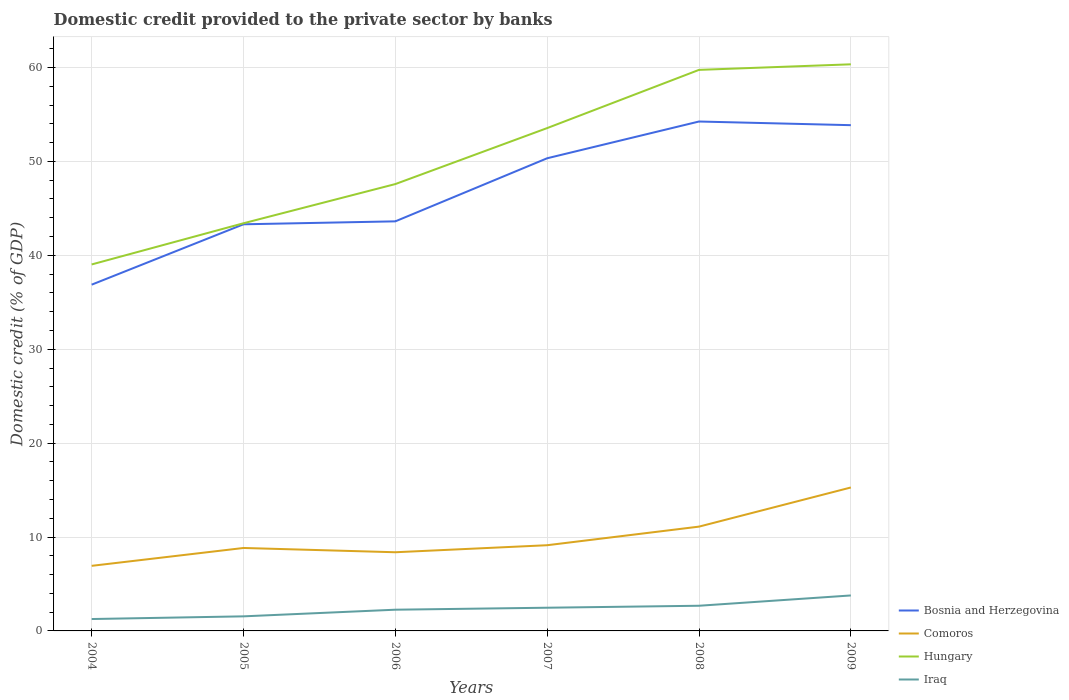Does the line corresponding to Bosnia and Herzegovina intersect with the line corresponding to Hungary?
Offer a very short reply. No. Is the number of lines equal to the number of legend labels?
Your answer should be very brief. Yes. Across all years, what is the maximum domestic credit provided to the private sector by banks in Comoros?
Your response must be concise. 6.93. In which year was the domestic credit provided to the private sector by banks in Iraq maximum?
Your answer should be compact. 2004. What is the total domestic credit provided to the private sector by banks in Hungary in the graph?
Provide a succinct answer. -6.79. What is the difference between the highest and the second highest domestic credit provided to the private sector by banks in Hungary?
Give a very brief answer. 21.31. What is the difference between the highest and the lowest domestic credit provided to the private sector by banks in Hungary?
Your answer should be compact. 3. Is the domestic credit provided to the private sector by banks in Hungary strictly greater than the domestic credit provided to the private sector by banks in Iraq over the years?
Give a very brief answer. No. What is the difference between two consecutive major ticks on the Y-axis?
Your answer should be very brief. 10. Are the values on the major ticks of Y-axis written in scientific E-notation?
Keep it short and to the point. No. Does the graph contain any zero values?
Keep it short and to the point. No. What is the title of the graph?
Your answer should be compact. Domestic credit provided to the private sector by banks. Does "North America" appear as one of the legend labels in the graph?
Make the answer very short. No. What is the label or title of the Y-axis?
Your response must be concise. Domestic credit (% of GDP). What is the Domestic credit (% of GDP) of Bosnia and Herzegovina in 2004?
Your response must be concise. 36.88. What is the Domestic credit (% of GDP) in Comoros in 2004?
Provide a succinct answer. 6.93. What is the Domestic credit (% of GDP) of Hungary in 2004?
Offer a terse response. 39.03. What is the Domestic credit (% of GDP) of Iraq in 2004?
Provide a succinct answer. 1.27. What is the Domestic credit (% of GDP) of Bosnia and Herzegovina in 2005?
Give a very brief answer. 43.31. What is the Domestic credit (% of GDP) of Comoros in 2005?
Give a very brief answer. 8.83. What is the Domestic credit (% of GDP) in Hungary in 2005?
Your response must be concise. 43.42. What is the Domestic credit (% of GDP) of Iraq in 2005?
Provide a succinct answer. 1.55. What is the Domestic credit (% of GDP) of Bosnia and Herzegovina in 2006?
Make the answer very short. 43.62. What is the Domestic credit (% of GDP) in Comoros in 2006?
Keep it short and to the point. 8.38. What is the Domestic credit (% of GDP) in Hungary in 2006?
Keep it short and to the point. 47.59. What is the Domestic credit (% of GDP) of Iraq in 2006?
Keep it short and to the point. 2.26. What is the Domestic credit (% of GDP) in Bosnia and Herzegovina in 2007?
Make the answer very short. 50.34. What is the Domestic credit (% of GDP) of Comoros in 2007?
Your answer should be very brief. 9.13. What is the Domestic credit (% of GDP) in Hungary in 2007?
Your answer should be very brief. 53.55. What is the Domestic credit (% of GDP) in Iraq in 2007?
Your response must be concise. 2.47. What is the Domestic credit (% of GDP) in Bosnia and Herzegovina in 2008?
Make the answer very short. 54.25. What is the Domestic credit (% of GDP) of Comoros in 2008?
Ensure brevity in your answer.  11.11. What is the Domestic credit (% of GDP) in Hungary in 2008?
Keep it short and to the point. 59.75. What is the Domestic credit (% of GDP) in Iraq in 2008?
Provide a short and direct response. 2.68. What is the Domestic credit (% of GDP) in Bosnia and Herzegovina in 2009?
Offer a very short reply. 53.86. What is the Domestic credit (% of GDP) in Comoros in 2009?
Provide a succinct answer. 15.28. What is the Domestic credit (% of GDP) of Hungary in 2009?
Your answer should be compact. 60.34. What is the Domestic credit (% of GDP) in Iraq in 2009?
Provide a short and direct response. 3.78. Across all years, what is the maximum Domestic credit (% of GDP) of Bosnia and Herzegovina?
Provide a succinct answer. 54.25. Across all years, what is the maximum Domestic credit (% of GDP) of Comoros?
Your answer should be compact. 15.28. Across all years, what is the maximum Domestic credit (% of GDP) in Hungary?
Your response must be concise. 60.34. Across all years, what is the maximum Domestic credit (% of GDP) in Iraq?
Give a very brief answer. 3.78. Across all years, what is the minimum Domestic credit (% of GDP) of Bosnia and Herzegovina?
Keep it short and to the point. 36.88. Across all years, what is the minimum Domestic credit (% of GDP) in Comoros?
Make the answer very short. 6.93. Across all years, what is the minimum Domestic credit (% of GDP) in Hungary?
Offer a terse response. 39.03. Across all years, what is the minimum Domestic credit (% of GDP) of Iraq?
Ensure brevity in your answer.  1.27. What is the total Domestic credit (% of GDP) in Bosnia and Herzegovina in the graph?
Keep it short and to the point. 282.25. What is the total Domestic credit (% of GDP) of Comoros in the graph?
Provide a short and direct response. 59.66. What is the total Domestic credit (% of GDP) of Hungary in the graph?
Keep it short and to the point. 303.68. What is the total Domestic credit (% of GDP) of Iraq in the graph?
Keep it short and to the point. 14.01. What is the difference between the Domestic credit (% of GDP) of Bosnia and Herzegovina in 2004 and that in 2005?
Your response must be concise. -6.43. What is the difference between the Domestic credit (% of GDP) in Comoros in 2004 and that in 2005?
Ensure brevity in your answer.  -1.9. What is the difference between the Domestic credit (% of GDP) in Hungary in 2004 and that in 2005?
Make the answer very short. -4.39. What is the difference between the Domestic credit (% of GDP) in Iraq in 2004 and that in 2005?
Keep it short and to the point. -0.29. What is the difference between the Domestic credit (% of GDP) in Bosnia and Herzegovina in 2004 and that in 2006?
Keep it short and to the point. -6.74. What is the difference between the Domestic credit (% of GDP) in Comoros in 2004 and that in 2006?
Your response must be concise. -1.45. What is the difference between the Domestic credit (% of GDP) of Hungary in 2004 and that in 2006?
Make the answer very short. -8.56. What is the difference between the Domestic credit (% of GDP) of Iraq in 2004 and that in 2006?
Ensure brevity in your answer.  -0.99. What is the difference between the Domestic credit (% of GDP) in Bosnia and Herzegovina in 2004 and that in 2007?
Offer a terse response. -13.46. What is the difference between the Domestic credit (% of GDP) of Comoros in 2004 and that in 2007?
Make the answer very short. -2.2. What is the difference between the Domestic credit (% of GDP) in Hungary in 2004 and that in 2007?
Offer a terse response. -14.52. What is the difference between the Domestic credit (% of GDP) of Iraq in 2004 and that in 2007?
Provide a short and direct response. -1.21. What is the difference between the Domestic credit (% of GDP) in Bosnia and Herzegovina in 2004 and that in 2008?
Ensure brevity in your answer.  -17.38. What is the difference between the Domestic credit (% of GDP) of Comoros in 2004 and that in 2008?
Offer a terse response. -4.18. What is the difference between the Domestic credit (% of GDP) in Hungary in 2004 and that in 2008?
Your answer should be very brief. -20.72. What is the difference between the Domestic credit (% of GDP) in Iraq in 2004 and that in 2008?
Keep it short and to the point. -1.41. What is the difference between the Domestic credit (% of GDP) of Bosnia and Herzegovina in 2004 and that in 2009?
Give a very brief answer. -16.98. What is the difference between the Domestic credit (% of GDP) in Comoros in 2004 and that in 2009?
Ensure brevity in your answer.  -8.34. What is the difference between the Domestic credit (% of GDP) in Hungary in 2004 and that in 2009?
Your answer should be very brief. -21.31. What is the difference between the Domestic credit (% of GDP) in Iraq in 2004 and that in 2009?
Your answer should be very brief. -2.51. What is the difference between the Domestic credit (% of GDP) of Bosnia and Herzegovina in 2005 and that in 2006?
Ensure brevity in your answer.  -0.31. What is the difference between the Domestic credit (% of GDP) in Comoros in 2005 and that in 2006?
Offer a very short reply. 0.45. What is the difference between the Domestic credit (% of GDP) of Hungary in 2005 and that in 2006?
Give a very brief answer. -4.17. What is the difference between the Domestic credit (% of GDP) of Iraq in 2005 and that in 2006?
Ensure brevity in your answer.  -0.71. What is the difference between the Domestic credit (% of GDP) of Bosnia and Herzegovina in 2005 and that in 2007?
Your answer should be very brief. -7.03. What is the difference between the Domestic credit (% of GDP) of Comoros in 2005 and that in 2007?
Offer a very short reply. -0.29. What is the difference between the Domestic credit (% of GDP) of Hungary in 2005 and that in 2007?
Keep it short and to the point. -10.14. What is the difference between the Domestic credit (% of GDP) of Iraq in 2005 and that in 2007?
Keep it short and to the point. -0.92. What is the difference between the Domestic credit (% of GDP) of Bosnia and Herzegovina in 2005 and that in 2008?
Offer a very short reply. -10.95. What is the difference between the Domestic credit (% of GDP) in Comoros in 2005 and that in 2008?
Your response must be concise. -2.27. What is the difference between the Domestic credit (% of GDP) of Hungary in 2005 and that in 2008?
Provide a succinct answer. -16.33. What is the difference between the Domestic credit (% of GDP) of Iraq in 2005 and that in 2008?
Your response must be concise. -1.13. What is the difference between the Domestic credit (% of GDP) in Bosnia and Herzegovina in 2005 and that in 2009?
Your answer should be very brief. -10.56. What is the difference between the Domestic credit (% of GDP) in Comoros in 2005 and that in 2009?
Give a very brief answer. -6.44. What is the difference between the Domestic credit (% of GDP) in Hungary in 2005 and that in 2009?
Offer a terse response. -16.93. What is the difference between the Domestic credit (% of GDP) in Iraq in 2005 and that in 2009?
Give a very brief answer. -2.23. What is the difference between the Domestic credit (% of GDP) of Bosnia and Herzegovina in 2006 and that in 2007?
Your answer should be compact. -6.72. What is the difference between the Domestic credit (% of GDP) of Comoros in 2006 and that in 2007?
Give a very brief answer. -0.75. What is the difference between the Domestic credit (% of GDP) of Hungary in 2006 and that in 2007?
Give a very brief answer. -5.96. What is the difference between the Domestic credit (% of GDP) in Iraq in 2006 and that in 2007?
Your answer should be compact. -0.21. What is the difference between the Domestic credit (% of GDP) in Bosnia and Herzegovina in 2006 and that in 2008?
Your answer should be compact. -10.63. What is the difference between the Domestic credit (% of GDP) in Comoros in 2006 and that in 2008?
Your answer should be very brief. -2.73. What is the difference between the Domestic credit (% of GDP) of Hungary in 2006 and that in 2008?
Keep it short and to the point. -12.16. What is the difference between the Domestic credit (% of GDP) of Iraq in 2006 and that in 2008?
Keep it short and to the point. -0.42. What is the difference between the Domestic credit (% of GDP) of Bosnia and Herzegovina in 2006 and that in 2009?
Your response must be concise. -10.24. What is the difference between the Domestic credit (% of GDP) of Comoros in 2006 and that in 2009?
Your answer should be very brief. -6.9. What is the difference between the Domestic credit (% of GDP) in Hungary in 2006 and that in 2009?
Ensure brevity in your answer.  -12.75. What is the difference between the Domestic credit (% of GDP) in Iraq in 2006 and that in 2009?
Offer a very short reply. -1.52. What is the difference between the Domestic credit (% of GDP) in Bosnia and Herzegovina in 2007 and that in 2008?
Make the answer very short. -3.91. What is the difference between the Domestic credit (% of GDP) of Comoros in 2007 and that in 2008?
Your response must be concise. -1.98. What is the difference between the Domestic credit (% of GDP) of Hungary in 2007 and that in 2008?
Offer a terse response. -6.2. What is the difference between the Domestic credit (% of GDP) of Iraq in 2007 and that in 2008?
Your answer should be very brief. -0.21. What is the difference between the Domestic credit (% of GDP) of Bosnia and Herzegovina in 2007 and that in 2009?
Give a very brief answer. -3.52. What is the difference between the Domestic credit (% of GDP) in Comoros in 2007 and that in 2009?
Provide a short and direct response. -6.15. What is the difference between the Domestic credit (% of GDP) of Hungary in 2007 and that in 2009?
Make the answer very short. -6.79. What is the difference between the Domestic credit (% of GDP) in Iraq in 2007 and that in 2009?
Keep it short and to the point. -1.31. What is the difference between the Domestic credit (% of GDP) in Bosnia and Herzegovina in 2008 and that in 2009?
Offer a very short reply. 0.39. What is the difference between the Domestic credit (% of GDP) in Comoros in 2008 and that in 2009?
Your response must be concise. -4.17. What is the difference between the Domestic credit (% of GDP) in Hungary in 2008 and that in 2009?
Offer a very short reply. -0.59. What is the difference between the Domestic credit (% of GDP) of Iraq in 2008 and that in 2009?
Make the answer very short. -1.1. What is the difference between the Domestic credit (% of GDP) of Bosnia and Herzegovina in 2004 and the Domestic credit (% of GDP) of Comoros in 2005?
Provide a short and direct response. 28.04. What is the difference between the Domestic credit (% of GDP) in Bosnia and Herzegovina in 2004 and the Domestic credit (% of GDP) in Hungary in 2005?
Your answer should be very brief. -6.54. What is the difference between the Domestic credit (% of GDP) of Bosnia and Herzegovina in 2004 and the Domestic credit (% of GDP) of Iraq in 2005?
Keep it short and to the point. 35.33. What is the difference between the Domestic credit (% of GDP) in Comoros in 2004 and the Domestic credit (% of GDP) in Hungary in 2005?
Your answer should be compact. -36.48. What is the difference between the Domestic credit (% of GDP) in Comoros in 2004 and the Domestic credit (% of GDP) in Iraq in 2005?
Give a very brief answer. 5.38. What is the difference between the Domestic credit (% of GDP) of Hungary in 2004 and the Domestic credit (% of GDP) of Iraq in 2005?
Offer a very short reply. 37.48. What is the difference between the Domestic credit (% of GDP) of Bosnia and Herzegovina in 2004 and the Domestic credit (% of GDP) of Comoros in 2006?
Your answer should be compact. 28.5. What is the difference between the Domestic credit (% of GDP) in Bosnia and Herzegovina in 2004 and the Domestic credit (% of GDP) in Hungary in 2006?
Your response must be concise. -10.71. What is the difference between the Domestic credit (% of GDP) in Bosnia and Herzegovina in 2004 and the Domestic credit (% of GDP) in Iraq in 2006?
Provide a succinct answer. 34.62. What is the difference between the Domestic credit (% of GDP) in Comoros in 2004 and the Domestic credit (% of GDP) in Hungary in 2006?
Give a very brief answer. -40.66. What is the difference between the Domestic credit (% of GDP) in Comoros in 2004 and the Domestic credit (% of GDP) in Iraq in 2006?
Your answer should be very brief. 4.67. What is the difference between the Domestic credit (% of GDP) of Hungary in 2004 and the Domestic credit (% of GDP) of Iraq in 2006?
Give a very brief answer. 36.77. What is the difference between the Domestic credit (% of GDP) of Bosnia and Herzegovina in 2004 and the Domestic credit (% of GDP) of Comoros in 2007?
Your answer should be very brief. 27.75. What is the difference between the Domestic credit (% of GDP) in Bosnia and Herzegovina in 2004 and the Domestic credit (% of GDP) in Hungary in 2007?
Provide a succinct answer. -16.68. What is the difference between the Domestic credit (% of GDP) of Bosnia and Herzegovina in 2004 and the Domestic credit (% of GDP) of Iraq in 2007?
Your answer should be compact. 34.41. What is the difference between the Domestic credit (% of GDP) of Comoros in 2004 and the Domestic credit (% of GDP) of Hungary in 2007?
Provide a succinct answer. -46.62. What is the difference between the Domestic credit (% of GDP) of Comoros in 2004 and the Domestic credit (% of GDP) of Iraq in 2007?
Give a very brief answer. 4.46. What is the difference between the Domestic credit (% of GDP) in Hungary in 2004 and the Domestic credit (% of GDP) in Iraq in 2007?
Your response must be concise. 36.56. What is the difference between the Domestic credit (% of GDP) in Bosnia and Herzegovina in 2004 and the Domestic credit (% of GDP) in Comoros in 2008?
Provide a succinct answer. 25.77. What is the difference between the Domestic credit (% of GDP) of Bosnia and Herzegovina in 2004 and the Domestic credit (% of GDP) of Hungary in 2008?
Your answer should be compact. -22.87. What is the difference between the Domestic credit (% of GDP) of Bosnia and Herzegovina in 2004 and the Domestic credit (% of GDP) of Iraq in 2008?
Give a very brief answer. 34.2. What is the difference between the Domestic credit (% of GDP) in Comoros in 2004 and the Domestic credit (% of GDP) in Hungary in 2008?
Provide a short and direct response. -52.82. What is the difference between the Domestic credit (% of GDP) of Comoros in 2004 and the Domestic credit (% of GDP) of Iraq in 2008?
Offer a very short reply. 4.25. What is the difference between the Domestic credit (% of GDP) in Hungary in 2004 and the Domestic credit (% of GDP) in Iraq in 2008?
Offer a very short reply. 36.35. What is the difference between the Domestic credit (% of GDP) in Bosnia and Herzegovina in 2004 and the Domestic credit (% of GDP) in Comoros in 2009?
Offer a very short reply. 21.6. What is the difference between the Domestic credit (% of GDP) in Bosnia and Herzegovina in 2004 and the Domestic credit (% of GDP) in Hungary in 2009?
Keep it short and to the point. -23.47. What is the difference between the Domestic credit (% of GDP) in Bosnia and Herzegovina in 2004 and the Domestic credit (% of GDP) in Iraq in 2009?
Your answer should be very brief. 33.1. What is the difference between the Domestic credit (% of GDP) of Comoros in 2004 and the Domestic credit (% of GDP) of Hungary in 2009?
Provide a short and direct response. -53.41. What is the difference between the Domestic credit (% of GDP) in Comoros in 2004 and the Domestic credit (% of GDP) in Iraq in 2009?
Your answer should be very brief. 3.15. What is the difference between the Domestic credit (% of GDP) of Hungary in 2004 and the Domestic credit (% of GDP) of Iraq in 2009?
Provide a short and direct response. 35.25. What is the difference between the Domestic credit (% of GDP) in Bosnia and Herzegovina in 2005 and the Domestic credit (% of GDP) in Comoros in 2006?
Make the answer very short. 34.93. What is the difference between the Domestic credit (% of GDP) of Bosnia and Herzegovina in 2005 and the Domestic credit (% of GDP) of Hungary in 2006?
Your response must be concise. -4.28. What is the difference between the Domestic credit (% of GDP) of Bosnia and Herzegovina in 2005 and the Domestic credit (% of GDP) of Iraq in 2006?
Provide a succinct answer. 41.05. What is the difference between the Domestic credit (% of GDP) in Comoros in 2005 and the Domestic credit (% of GDP) in Hungary in 2006?
Keep it short and to the point. -38.76. What is the difference between the Domestic credit (% of GDP) of Comoros in 2005 and the Domestic credit (% of GDP) of Iraq in 2006?
Keep it short and to the point. 6.57. What is the difference between the Domestic credit (% of GDP) of Hungary in 2005 and the Domestic credit (% of GDP) of Iraq in 2006?
Offer a terse response. 41.16. What is the difference between the Domestic credit (% of GDP) in Bosnia and Herzegovina in 2005 and the Domestic credit (% of GDP) in Comoros in 2007?
Ensure brevity in your answer.  34.18. What is the difference between the Domestic credit (% of GDP) in Bosnia and Herzegovina in 2005 and the Domestic credit (% of GDP) in Hungary in 2007?
Your response must be concise. -10.25. What is the difference between the Domestic credit (% of GDP) in Bosnia and Herzegovina in 2005 and the Domestic credit (% of GDP) in Iraq in 2007?
Keep it short and to the point. 40.83. What is the difference between the Domestic credit (% of GDP) of Comoros in 2005 and the Domestic credit (% of GDP) of Hungary in 2007?
Give a very brief answer. -44.72. What is the difference between the Domestic credit (% of GDP) of Comoros in 2005 and the Domestic credit (% of GDP) of Iraq in 2007?
Provide a succinct answer. 6.36. What is the difference between the Domestic credit (% of GDP) in Hungary in 2005 and the Domestic credit (% of GDP) in Iraq in 2007?
Offer a terse response. 40.95. What is the difference between the Domestic credit (% of GDP) of Bosnia and Herzegovina in 2005 and the Domestic credit (% of GDP) of Comoros in 2008?
Give a very brief answer. 32.2. What is the difference between the Domestic credit (% of GDP) in Bosnia and Herzegovina in 2005 and the Domestic credit (% of GDP) in Hungary in 2008?
Offer a very short reply. -16.45. What is the difference between the Domestic credit (% of GDP) of Bosnia and Herzegovina in 2005 and the Domestic credit (% of GDP) of Iraq in 2008?
Provide a succinct answer. 40.63. What is the difference between the Domestic credit (% of GDP) in Comoros in 2005 and the Domestic credit (% of GDP) in Hungary in 2008?
Offer a very short reply. -50.92. What is the difference between the Domestic credit (% of GDP) in Comoros in 2005 and the Domestic credit (% of GDP) in Iraq in 2008?
Your response must be concise. 6.15. What is the difference between the Domestic credit (% of GDP) in Hungary in 2005 and the Domestic credit (% of GDP) in Iraq in 2008?
Ensure brevity in your answer.  40.74. What is the difference between the Domestic credit (% of GDP) in Bosnia and Herzegovina in 2005 and the Domestic credit (% of GDP) in Comoros in 2009?
Your answer should be compact. 28.03. What is the difference between the Domestic credit (% of GDP) in Bosnia and Herzegovina in 2005 and the Domestic credit (% of GDP) in Hungary in 2009?
Ensure brevity in your answer.  -17.04. What is the difference between the Domestic credit (% of GDP) of Bosnia and Herzegovina in 2005 and the Domestic credit (% of GDP) of Iraq in 2009?
Make the answer very short. 39.53. What is the difference between the Domestic credit (% of GDP) in Comoros in 2005 and the Domestic credit (% of GDP) in Hungary in 2009?
Your response must be concise. -51.51. What is the difference between the Domestic credit (% of GDP) of Comoros in 2005 and the Domestic credit (% of GDP) of Iraq in 2009?
Provide a succinct answer. 5.06. What is the difference between the Domestic credit (% of GDP) in Hungary in 2005 and the Domestic credit (% of GDP) in Iraq in 2009?
Your response must be concise. 39.64. What is the difference between the Domestic credit (% of GDP) in Bosnia and Herzegovina in 2006 and the Domestic credit (% of GDP) in Comoros in 2007?
Provide a succinct answer. 34.49. What is the difference between the Domestic credit (% of GDP) of Bosnia and Herzegovina in 2006 and the Domestic credit (% of GDP) of Hungary in 2007?
Your answer should be very brief. -9.93. What is the difference between the Domestic credit (% of GDP) in Bosnia and Herzegovina in 2006 and the Domestic credit (% of GDP) in Iraq in 2007?
Your response must be concise. 41.15. What is the difference between the Domestic credit (% of GDP) of Comoros in 2006 and the Domestic credit (% of GDP) of Hungary in 2007?
Your response must be concise. -45.17. What is the difference between the Domestic credit (% of GDP) in Comoros in 2006 and the Domestic credit (% of GDP) in Iraq in 2007?
Your answer should be very brief. 5.91. What is the difference between the Domestic credit (% of GDP) of Hungary in 2006 and the Domestic credit (% of GDP) of Iraq in 2007?
Give a very brief answer. 45.12. What is the difference between the Domestic credit (% of GDP) in Bosnia and Herzegovina in 2006 and the Domestic credit (% of GDP) in Comoros in 2008?
Keep it short and to the point. 32.51. What is the difference between the Domestic credit (% of GDP) in Bosnia and Herzegovina in 2006 and the Domestic credit (% of GDP) in Hungary in 2008?
Your answer should be very brief. -16.13. What is the difference between the Domestic credit (% of GDP) in Bosnia and Herzegovina in 2006 and the Domestic credit (% of GDP) in Iraq in 2008?
Make the answer very short. 40.94. What is the difference between the Domestic credit (% of GDP) of Comoros in 2006 and the Domestic credit (% of GDP) of Hungary in 2008?
Offer a terse response. -51.37. What is the difference between the Domestic credit (% of GDP) of Comoros in 2006 and the Domestic credit (% of GDP) of Iraq in 2008?
Ensure brevity in your answer.  5.7. What is the difference between the Domestic credit (% of GDP) of Hungary in 2006 and the Domestic credit (% of GDP) of Iraq in 2008?
Ensure brevity in your answer.  44.91. What is the difference between the Domestic credit (% of GDP) in Bosnia and Herzegovina in 2006 and the Domestic credit (% of GDP) in Comoros in 2009?
Give a very brief answer. 28.34. What is the difference between the Domestic credit (% of GDP) in Bosnia and Herzegovina in 2006 and the Domestic credit (% of GDP) in Hungary in 2009?
Make the answer very short. -16.72. What is the difference between the Domestic credit (% of GDP) of Bosnia and Herzegovina in 2006 and the Domestic credit (% of GDP) of Iraq in 2009?
Your answer should be very brief. 39.84. What is the difference between the Domestic credit (% of GDP) in Comoros in 2006 and the Domestic credit (% of GDP) in Hungary in 2009?
Your answer should be compact. -51.96. What is the difference between the Domestic credit (% of GDP) of Comoros in 2006 and the Domestic credit (% of GDP) of Iraq in 2009?
Your response must be concise. 4.6. What is the difference between the Domestic credit (% of GDP) of Hungary in 2006 and the Domestic credit (% of GDP) of Iraq in 2009?
Offer a very short reply. 43.81. What is the difference between the Domestic credit (% of GDP) of Bosnia and Herzegovina in 2007 and the Domestic credit (% of GDP) of Comoros in 2008?
Offer a terse response. 39.23. What is the difference between the Domestic credit (% of GDP) in Bosnia and Herzegovina in 2007 and the Domestic credit (% of GDP) in Hungary in 2008?
Your answer should be compact. -9.41. What is the difference between the Domestic credit (% of GDP) in Bosnia and Herzegovina in 2007 and the Domestic credit (% of GDP) in Iraq in 2008?
Your response must be concise. 47.66. What is the difference between the Domestic credit (% of GDP) in Comoros in 2007 and the Domestic credit (% of GDP) in Hungary in 2008?
Provide a succinct answer. -50.62. What is the difference between the Domestic credit (% of GDP) in Comoros in 2007 and the Domestic credit (% of GDP) in Iraq in 2008?
Your answer should be compact. 6.45. What is the difference between the Domestic credit (% of GDP) in Hungary in 2007 and the Domestic credit (% of GDP) in Iraq in 2008?
Provide a short and direct response. 50.87. What is the difference between the Domestic credit (% of GDP) of Bosnia and Herzegovina in 2007 and the Domestic credit (% of GDP) of Comoros in 2009?
Provide a succinct answer. 35.06. What is the difference between the Domestic credit (% of GDP) in Bosnia and Herzegovina in 2007 and the Domestic credit (% of GDP) in Hungary in 2009?
Your answer should be very brief. -10.01. What is the difference between the Domestic credit (% of GDP) in Bosnia and Herzegovina in 2007 and the Domestic credit (% of GDP) in Iraq in 2009?
Ensure brevity in your answer.  46.56. What is the difference between the Domestic credit (% of GDP) of Comoros in 2007 and the Domestic credit (% of GDP) of Hungary in 2009?
Keep it short and to the point. -51.22. What is the difference between the Domestic credit (% of GDP) in Comoros in 2007 and the Domestic credit (% of GDP) in Iraq in 2009?
Provide a short and direct response. 5.35. What is the difference between the Domestic credit (% of GDP) in Hungary in 2007 and the Domestic credit (% of GDP) in Iraq in 2009?
Offer a very short reply. 49.77. What is the difference between the Domestic credit (% of GDP) of Bosnia and Herzegovina in 2008 and the Domestic credit (% of GDP) of Comoros in 2009?
Offer a terse response. 38.98. What is the difference between the Domestic credit (% of GDP) of Bosnia and Herzegovina in 2008 and the Domestic credit (% of GDP) of Hungary in 2009?
Provide a short and direct response. -6.09. What is the difference between the Domestic credit (% of GDP) of Bosnia and Herzegovina in 2008 and the Domestic credit (% of GDP) of Iraq in 2009?
Ensure brevity in your answer.  50.47. What is the difference between the Domestic credit (% of GDP) in Comoros in 2008 and the Domestic credit (% of GDP) in Hungary in 2009?
Your answer should be very brief. -49.24. What is the difference between the Domestic credit (% of GDP) of Comoros in 2008 and the Domestic credit (% of GDP) of Iraq in 2009?
Make the answer very short. 7.33. What is the difference between the Domestic credit (% of GDP) in Hungary in 2008 and the Domestic credit (% of GDP) in Iraq in 2009?
Your response must be concise. 55.97. What is the average Domestic credit (% of GDP) of Bosnia and Herzegovina per year?
Provide a succinct answer. 47.04. What is the average Domestic credit (% of GDP) in Comoros per year?
Your answer should be compact. 9.94. What is the average Domestic credit (% of GDP) in Hungary per year?
Offer a very short reply. 50.61. What is the average Domestic credit (% of GDP) of Iraq per year?
Your answer should be compact. 2.33. In the year 2004, what is the difference between the Domestic credit (% of GDP) of Bosnia and Herzegovina and Domestic credit (% of GDP) of Comoros?
Provide a succinct answer. 29.95. In the year 2004, what is the difference between the Domestic credit (% of GDP) in Bosnia and Herzegovina and Domestic credit (% of GDP) in Hungary?
Ensure brevity in your answer.  -2.15. In the year 2004, what is the difference between the Domestic credit (% of GDP) of Bosnia and Herzegovina and Domestic credit (% of GDP) of Iraq?
Keep it short and to the point. 35.61. In the year 2004, what is the difference between the Domestic credit (% of GDP) in Comoros and Domestic credit (% of GDP) in Hungary?
Your answer should be very brief. -32.1. In the year 2004, what is the difference between the Domestic credit (% of GDP) of Comoros and Domestic credit (% of GDP) of Iraq?
Make the answer very short. 5.67. In the year 2004, what is the difference between the Domestic credit (% of GDP) in Hungary and Domestic credit (% of GDP) in Iraq?
Provide a succinct answer. 37.76. In the year 2005, what is the difference between the Domestic credit (% of GDP) of Bosnia and Herzegovina and Domestic credit (% of GDP) of Comoros?
Offer a very short reply. 34.47. In the year 2005, what is the difference between the Domestic credit (% of GDP) of Bosnia and Herzegovina and Domestic credit (% of GDP) of Hungary?
Provide a short and direct response. -0.11. In the year 2005, what is the difference between the Domestic credit (% of GDP) in Bosnia and Herzegovina and Domestic credit (% of GDP) in Iraq?
Offer a very short reply. 41.75. In the year 2005, what is the difference between the Domestic credit (% of GDP) of Comoros and Domestic credit (% of GDP) of Hungary?
Ensure brevity in your answer.  -34.58. In the year 2005, what is the difference between the Domestic credit (% of GDP) of Comoros and Domestic credit (% of GDP) of Iraq?
Provide a short and direct response. 7.28. In the year 2005, what is the difference between the Domestic credit (% of GDP) of Hungary and Domestic credit (% of GDP) of Iraq?
Provide a succinct answer. 41.86. In the year 2006, what is the difference between the Domestic credit (% of GDP) in Bosnia and Herzegovina and Domestic credit (% of GDP) in Comoros?
Provide a short and direct response. 35.24. In the year 2006, what is the difference between the Domestic credit (% of GDP) of Bosnia and Herzegovina and Domestic credit (% of GDP) of Hungary?
Keep it short and to the point. -3.97. In the year 2006, what is the difference between the Domestic credit (% of GDP) in Bosnia and Herzegovina and Domestic credit (% of GDP) in Iraq?
Your answer should be very brief. 41.36. In the year 2006, what is the difference between the Domestic credit (% of GDP) of Comoros and Domestic credit (% of GDP) of Hungary?
Keep it short and to the point. -39.21. In the year 2006, what is the difference between the Domestic credit (% of GDP) in Comoros and Domestic credit (% of GDP) in Iraq?
Provide a succinct answer. 6.12. In the year 2006, what is the difference between the Domestic credit (% of GDP) in Hungary and Domestic credit (% of GDP) in Iraq?
Give a very brief answer. 45.33. In the year 2007, what is the difference between the Domestic credit (% of GDP) of Bosnia and Herzegovina and Domestic credit (% of GDP) of Comoros?
Your answer should be compact. 41.21. In the year 2007, what is the difference between the Domestic credit (% of GDP) in Bosnia and Herzegovina and Domestic credit (% of GDP) in Hungary?
Your answer should be very brief. -3.21. In the year 2007, what is the difference between the Domestic credit (% of GDP) in Bosnia and Herzegovina and Domestic credit (% of GDP) in Iraq?
Offer a very short reply. 47.87. In the year 2007, what is the difference between the Domestic credit (% of GDP) in Comoros and Domestic credit (% of GDP) in Hungary?
Give a very brief answer. -44.42. In the year 2007, what is the difference between the Domestic credit (% of GDP) of Comoros and Domestic credit (% of GDP) of Iraq?
Your answer should be very brief. 6.66. In the year 2007, what is the difference between the Domestic credit (% of GDP) of Hungary and Domestic credit (% of GDP) of Iraq?
Offer a very short reply. 51.08. In the year 2008, what is the difference between the Domestic credit (% of GDP) of Bosnia and Herzegovina and Domestic credit (% of GDP) of Comoros?
Provide a succinct answer. 43.14. In the year 2008, what is the difference between the Domestic credit (% of GDP) of Bosnia and Herzegovina and Domestic credit (% of GDP) of Hungary?
Your response must be concise. -5.5. In the year 2008, what is the difference between the Domestic credit (% of GDP) in Bosnia and Herzegovina and Domestic credit (% of GDP) in Iraq?
Your response must be concise. 51.57. In the year 2008, what is the difference between the Domestic credit (% of GDP) in Comoros and Domestic credit (% of GDP) in Hungary?
Offer a very short reply. -48.64. In the year 2008, what is the difference between the Domestic credit (% of GDP) in Comoros and Domestic credit (% of GDP) in Iraq?
Your response must be concise. 8.43. In the year 2008, what is the difference between the Domestic credit (% of GDP) in Hungary and Domestic credit (% of GDP) in Iraq?
Offer a terse response. 57.07. In the year 2009, what is the difference between the Domestic credit (% of GDP) of Bosnia and Herzegovina and Domestic credit (% of GDP) of Comoros?
Keep it short and to the point. 38.59. In the year 2009, what is the difference between the Domestic credit (% of GDP) of Bosnia and Herzegovina and Domestic credit (% of GDP) of Hungary?
Offer a terse response. -6.48. In the year 2009, what is the difference between the Domestic credit (% of GDP) in Bosnia and Herzegovina and Domestic credit (% of GDP) in Iraq?
Offer a very short reply. 50.08. In the year 2009, what is the difference between the Domestic credit (% of GDP) of Comoros and Domestic credit (% of GDP) of Hungary?
Provide a succinct answer. -45.07. In the year 2009, what is the difference between the Domestic credit (% of GDP) of Comoros and Domestic credit (% of GDP) of Iraq?
Make the answer very short. 11.5. In the year 2009, what is the difference between the Domestic credit (% of GDP) in Hungary and Domestic credit (% of GDP) in Iraq?
Your response must be concise. 56.57. What is the ratio of the Domestic credit (% of GDP) in Bosnia and Herzegovina in 2004 to that in 2005?
Give a very brief answer. 0.85. What is the ratio of the Domestic credit (% of GDP) in Comoros in 2004 to that in 2005?
Ensure brevity in your answer.  0.78. What is the ratio of the Domestic credit (% of GDP) of Hungary in 2004 to that in 2005?
Make the answer very short. 0.9. What is the ratio of the Domestic credit (% of GDP) of Iraq in 2004 to that in 2005?
Provide a succinct answer. 0.82. What is the ratio of the Domestic credit (% of GDP) of Bosnia and Herzegovina in 2004 to that in 2006?
Provide a succinct answer. 0.85. What is the ratio of the Domestic credit (% of GDP) of Comoros in 2004 to that in 2006?
Provide a succinct answer. 0.83. What is the ratio of the Domestic credit (% of GDP) in Hungary in 2004 to that in 2006?
Make the answer very short. 0.82. What is the ratio of the Domestic credit (% of GDP) in Iraq in 2004 to that in 2006?
Ensure brevity in your answer.  0.56. What is the ratio of the Domestic credit (% of GDP) of Bosnia and Herzegovina in 2004 to that in 2007?
Give a very brief answer. 0.73. What is the ratio of the Domestic credit (% of GDP) of Comoros in 2004 to that in 2007?
Your answer should be very brief. 0.76. What is the ratio of the Domestic credit (% of GDP) in Hungary in 2004 to that in 2007?
Your answer should be very brief. 0.73. What is the ratio of the Domestic credit (% of GDP) of Iraq in 2004 to that in 2007?
Ensure brevity in your answer.  0.51. What is the ratio of the Domestic credit (% of GDP) in Bosnia and Herzegovina in 2004 to that in 2008?
Make the answer very short. 0.68. What is the ratio of the Domestic credit (% of GDP) in Comoros in 2004 to that in 2008?
Keep it short and to the point. 0.62. What is the ratio of the Domestic credit (% of GDP) in Hungary in 2004 to that in 2008?
Give a very brief answer. 0.65. What is the ratio of the Domestic credit (% of GDP) of Iraq in 2004 to that in 2008?
Ensure brevity in your answer.  0.47. What is the ratio of the Domestic credit (% of GDP) of Bosnia and Herzegovina in 2004 to that in 2009?
Your answer should be very brief. 0.68. What is the ratio of the Domestic credit (% of GDP) in Comoros in 2004 to that in 2009?
Offer a very short reply. 0.45. What is the ratio of the Domestic credit (% of GDP) of Hungary in 2004 to that in 2009?
Keep it short and to the point. 0.65. What is the ratio of the Domestic credit (% of GDP) in Iraq in 2004 to that in 2009?
Your answer should be compact. 0.34. What is the ratio of the Domestic credit (% of GDP) in Comoros in 2005 to that in 2006?
Your response must be concise. 1.05. What is the ratio of the Domestic credit (% of GDP) in Hungary in 2005 to that in 2006?
Your response must be concise. 0.91. What is the ratio of the Domestic credit (% of GDP) of Iraq in 2005 to that in 2006?
Your answer should be compact. 0.69. What is the ratio of the Domestic credit (% of GDP) in Bosnia and Herzegovina in 2005 to that in 2007?
Your response must be concise. 0.86. What is the ratio of the Domestic credit (% of GDP) of Comoros in 2005 to that in 2007?
Your answer should be compact. 0.97. What is the ratio of the Domestic credit (% of GDP) of Hungary in 2005 to that in 2007?
Your response must be concise. 0.81. What is the ratio of the Domestic credit (% of GDP) in Iraq in 2005 to that in 2007?
Give a very brief answer. 0.63. What is the ratio of the Domestic credit (% of GDP) in Bosnia and Herzegovina in 2005 to that in 2008?
Provide a short and direct response. 0.8. What is the ratio of the Domestic credit (% of GDP) in Comoros in 2005 to that in 2008?
Keep it short and to the point. 0.8. What is the ratio of the Domestic credit (% of GDP) in Hungary in 2005 to that in 2008?
Your answer should be very brief. 0.73. What is the ratio of the Domestic credit (% of GDP) of Iraq in 2005 to that in 2008?
Your answer should be compact. 0.58. What is the ratio of the Domestic credit (% of GDP) of Bosnia and Herzegovina in 2005 to that in 2009?
Provide a short and direct response. 0.8. What is the ratio of the Domestic credit (% of GDP) of Comoros in 2005 to that in 2009?
Provide a short and direct response. 0.58. What is the ratio of the Domestic credit (% of GDP) of Hungary in 2005 to that in 2009?
Your response must be concise. 0.72. What is the ratio of the Domestic credit (% of GDP) in Iraq in 2005 to that in 2009?
Ensure brevity in your answer.  0.41. What is the ratio of the Domestic credit (% of GDP) in Bosnia and Herzegovina in 2006 to that in 2007?
Ensure brevity in your answer.  0.87. What is the ratio of the Domestic credit (% of GDP) in Comoros in 2006 to that in 2007?
Provide a succinct answer. 0.92. What is the ratio of the Domestic credit (% of GDP) in Hungary in 2006 to that in 2007?
Your answer should be compact. 0.89. What is the ratio of the Domestic credit (% of GDP) of Iraq in 2006 to that in 2007?
Your answer should be very brief. 0.91. What is the ratio of the Domestic credit (% of GDP) of Bosnia and Herzegovina in 2006 to that in 2008?
Your response must be concise. 0.8. What is the ratio of the Domestic credit (% of GDP) in Comoros in 2006 to that in 2008?
Ensure brevity in your answer.  0.75. What is the ratio of the Domestic credit (% of GDP) of Hungary in 2006 to that in 2008?
Offer a very short reply. 0.8. What is the ratio of the Domestic credit (% of GDP) in Iraq in 2006 to that in 2008?
Make the answer very short. 0.84. What is the ratio of the Domestic credit (% of GDP) of Bosnia and Herzegovina in 2006 to that in 2009?
Provide a succinct answer. 0.81. What is the ratio of the Domestic credit (% of GDP) in Comoros in 2006 to that in 2009?
Give a very brief answer. 0.55. What is the ratio of the Domestic credit (% of GDP) in Hungary in 2006 to that in 2009?
Offer a very short reply. 0.79. What is the ratio of the Domestic credit (% of GDP) of Iraq in 2006 to that in 2009?
Your response must be concise. 0.6. What is the ratio of the Domestic credit (% of GDP) of Bosnia and Herzegovina in 2007 to that in 2008?
Keep it short and to the point. 0.93. What is the ratio of the Domestic credit (% of GDP) in Comoros in 2007 to that in 2008?
Provide a short and direct response. 0.82. What is the ratio of the Domestic credit (% of GDP) in Hungary in 2007 to that in 2008?
Give a very brief answer. 0.9. What is the ratio of the Domestic credit (% of GDP) of Iraq in 2007 to that in 2008?
Keep it short and to the point. 0.92. What is the ratio of the Domestic credit (% of GDP) in Bosnia and Herzegovina in 2007 to that in 2009?
Provide a short and direct response. 0.93. What is the ratio of the Domestic credit (% of GDP) in Comoros in 2007 to that in 2009?
Ensure brevity in your answer.  0.6. What is the ratio of the Domestic credit (% of GDP) in Hungary in 2007 to that in 2009?
Give a very brief answer. 0.89. What is the ratio of the Domestic credit (% of GDP) in Iraq in 2007 to that in 2009?
Your answer should be compact. 0.65. What is the ratio of the Domestic credit (% of GDP) of Bosnia and Herzegovina in 2008 to that in 2009?
Provide a short and direct response. 1.01. What is the ratio of the Domestic credit (% of GDP) in Comoros in 2008 to that in 2009?
Offer a terse response. 0.73. What is the ratio of the Domestic credit (% of GDP) of Hungary in 2008 to that in 2009?
Provide a short and direct response. 0.99. What is the ratio of the Domestic credit (% of GDP) of Iraq in 2008 to that in 2009?
Offer a terse response. 0.71. What is the difference between the highest and the second highest Domestic credit (% of GDP) in Bosnia and Herzegovina?
Provide a succinct answer. 0.39. What is the difference between the highest and the second highest Domestic credit (% of GDP) of Comoros?
Keep it short and to the point. 4.17. What is the difference between the highest and the second highest Domestic credit (% of GDP) of Hungary?
Provide a succinct answer. 0.59. What is the difference between the highest and the second highest Domestic credit (% of GDP) of Iraq?
Provide a succinct answer. 1.1. What is the difference between the highest and the lowest Domestic credit (% of GDP) in Bosnia and Herzegovina?
Make the answer very short. 17.38. What is the difference between the highest and the lowest Domestic credit (% of GDP) in Comoros?
Keep it short and to the point. 8.34. What is the difference between the highest and the lowest Domestic credit (% of GDP) in Hungary?
Your answer should be compact. 21.31. What is the difference between the highest and the lowest Domestic credit (% of GDP) of Iraq?
Keep it short and to the point. 2.51. 